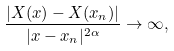Convert formula to latex. <formula><loc_0><loc_0><loc_500><loc_500>\frac { | X ( x ) - X ( x _ { n } ) | } { | x - x _ { n } | ^ { 2 \alpha } } \to \infty ,</formula> 